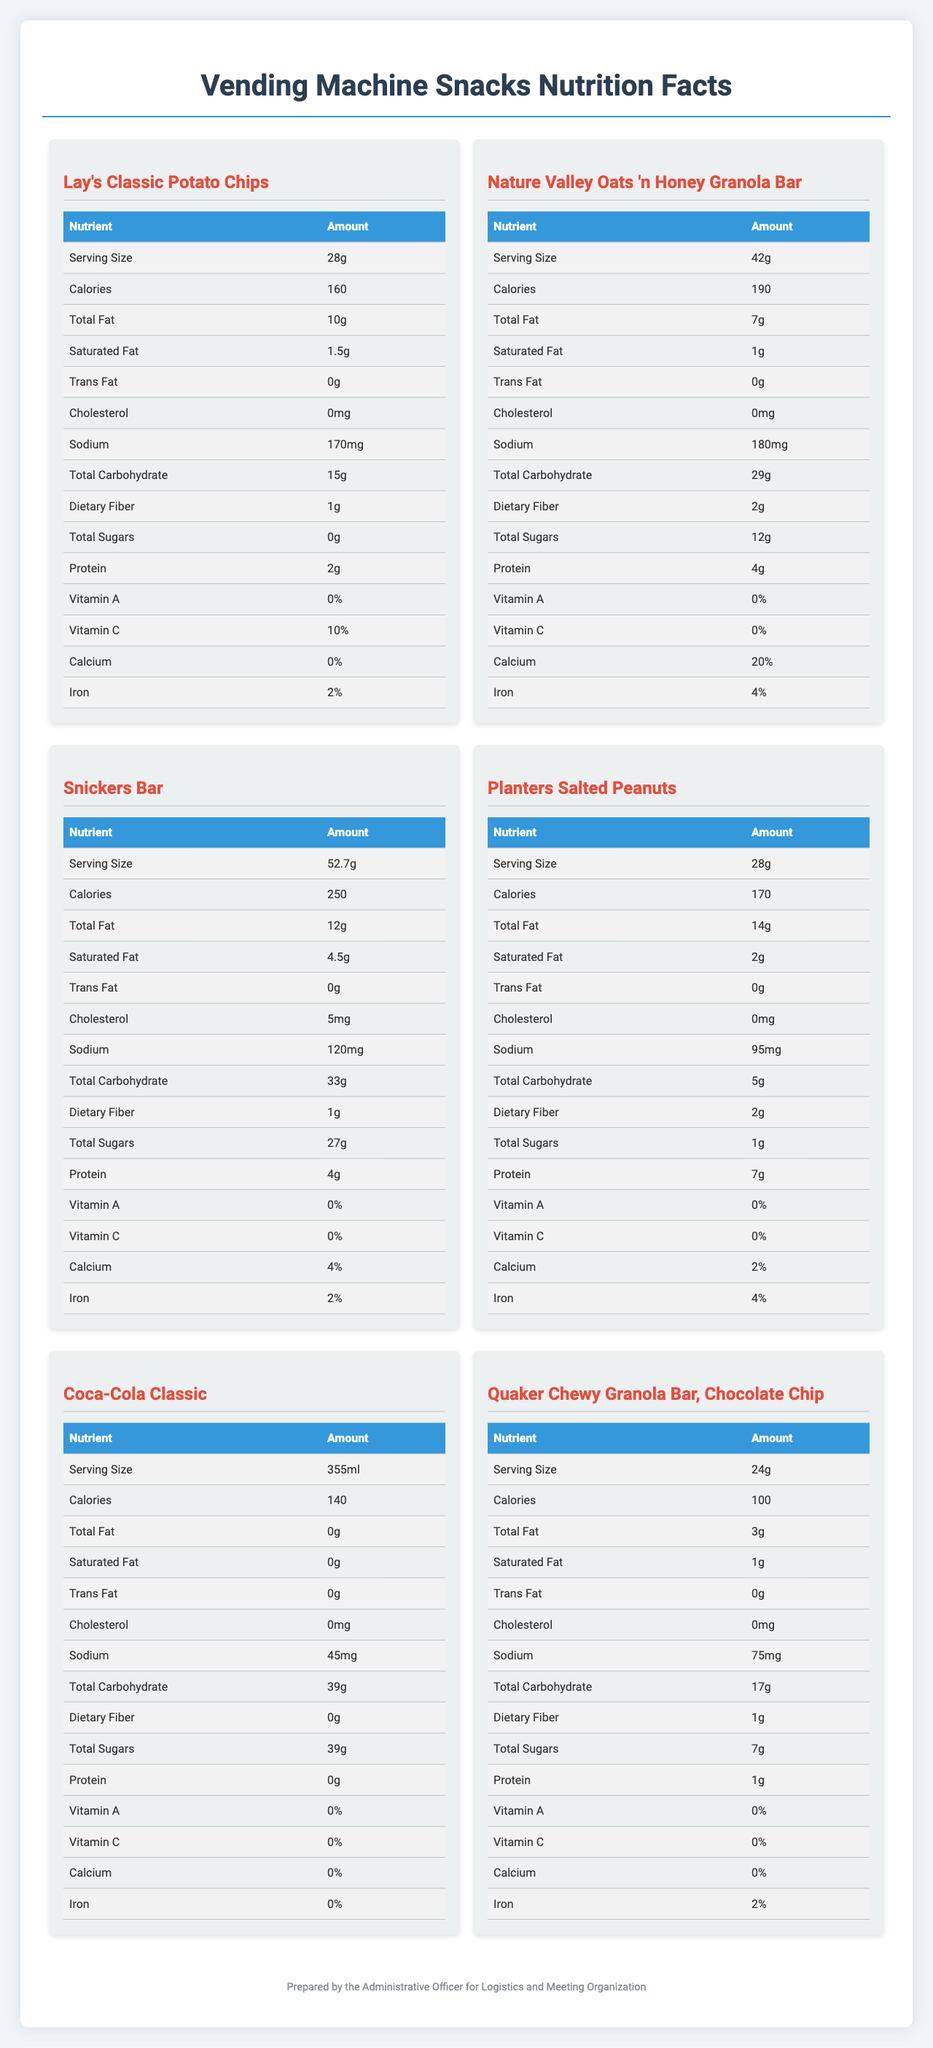what is the serving size of Lay's Classic Potato Chips? The serving size for Lay's Classic Potato Chips is listed as 28g in the document.
Answer: 28g How many calories are there in a Snickers Bar? The document mentions that one Snickers Bar contains 250 calories.
Answer: 250 Which snack has the highest amount of total sugars? The Snickers Bar has 27g of total sugars, which is the highest among the listed snacks.
Answer: Snickers Bar Which snack has the highest sodium content? The Nature Valley Oats 'n Honey Granola Bar contains 180mg of sodium, the highest among the listed options.
Answer: Nature Valley Oats 'n Honey Granola Bar What is the total fat content in Planters Salted Peanuts? The total fat content in Planters Salted Peanuts is listed as 14g.
Answer: 14g Which snack has zero cholesterol content? A. Snickers Bar B. Lay's Classic Potato Chips C. Planters Salted Peanuts D. Coca-Cola Classic Both Lay's Classic Potato Chips and Coca-Cola Classic contain 0mg of cholesterol.
Answer: B and D Which of these snacks has the least total carbohydrates? I. Lay's Classic Potato Chips II. Snickers Bar III. Planters Salted Peanuts IV. Nature Valley Oats 'n Honey Granola Bar Planters Salted Peanuts have the least carbohydrates with 5g.
Answer: III Is the dietary fiber content of Quaker Chewy Granola Bar higher than that of Lay's Classic Potato Chips? The dietary fiber content of Quaker Chewy Granola Bar is 1g, which is the same as Lay's Classic Potato Chips.
Answer: No Summarize the main idea of the document. The document is designed to help understand the nutritional content of the vending machine snacks and provide guidelines for selecting and managing snacks during meetings.
Answer: The document presents the nutritional breakdown of various snacks available in office vending machines. It includes details such as serving size, calories, total fat, saturated fat, trans fat, cholesterol, sodium, total carbohydrates, dietary fiber, total sugars, protein, and vitamins. Additionally, it outlines considerations for meeting room snacks and administrative tasks related to logistics and organization. How many milligrams of cholesterol are present in Coca-Cola Classic? The appropriate unit of measurement for cholesterol would be in milligrams (mg), but the document lists cholesterol content as 0mg. Hence, determining the milligrams is not required.
Answer: Cannot be determined 